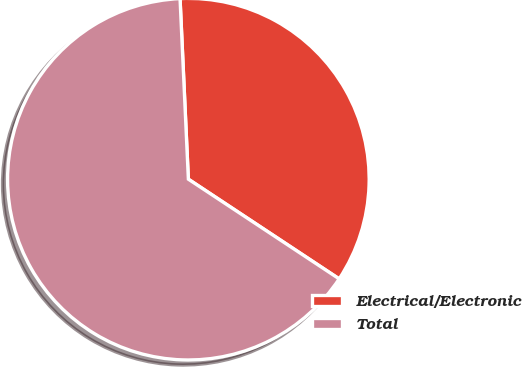<chart> <loc_0><loc_0><loc_500><loc_500><pie_chart><fcel>Electrical/Electronic<fcel>Total<nl><fcel>35.03%<fcel>64.97%<nl></chart> 